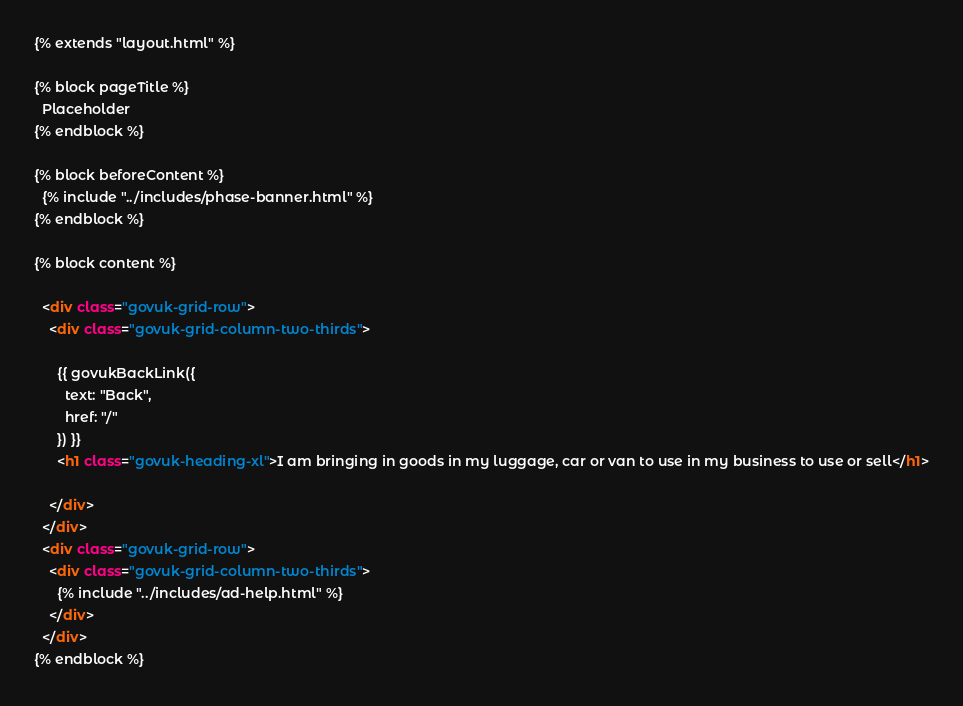Convert code to text. <code><loc_0><loc_0><loc_500><loc_500><_HTML_>{% extends "layout.html" %}

{% block pageTitle %}
  Placeholder
{% endblock %}

{% block beforeContent %}
  {% include "../includes/phase-banner.html" %}
{% endblock %}

{% block content %}

  <div class="govuk-grid-row">
    <div class="govuk-grid-column-two-thirds">

      {{ govukBackLink({
        text: "Back",
        href: "/"
      }) }}
      <h1 class="govuk-heading-xl">I am bringing in goods in my luggage, car or van to use in my business to use or sell</h1>

    </div>
  </div>
  <div class="govuk-grid-row">
    <div class="govuk-grid-column-two-thirds">
      {% include "../includes/ad-help.html" %}
    </div>
  </div>
{% endblock %}</code> 